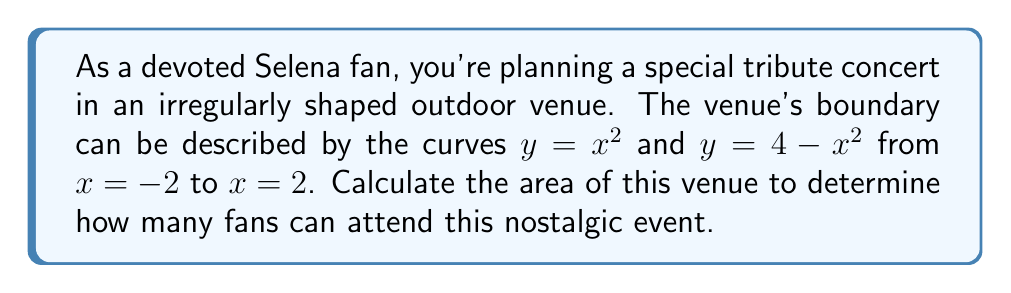Show me your answer to this math problem. To find the area of this irregularly shaped concert venue, we need to use polynomial integration. Let's approach this step-by-step:

1) The area is bounded by two curves: $y = x^2$ (lower curve) and $y = 4 - x^2$ (upper curve), from $x = -2$ to $x = 2$.

2) To find the area between these curves, we need to integrate the difference between the upper and lower functions:

   $$A = \int_{-2}^{2} [(4 - x^2) - x^2] dx$$

3) Simplify the integrand:
   $$A = \int_{-2}^{2} [4 - 2x^2] dx$$

4) Integrate:
   $$A = [4x - \frac{2x^3}{3}]_{-2}^{2}$$

5) Evaluate the integral at the bounds:
   $$A = (4(2) - \frac{2(2^3)}{3}) - (4(-2) - \frac{2(-2^3)}{3})$$
   $$A = (8 - \frac{16}{3}) - (-8 - \frac{-16}{3})$$

6) Simplify:
   $$A = (8 - \frac{16}{3}) + (8 + \frac{16}{3})$$
   $$A = 16$$

Therefore, the area of the concert venue is 16 square units.

[asy]
size(200);
import graph;

real f(real x) {return x^2;}
real g(real x) {return 4-x^2;}

draw(graph(f,-2,2),blue);
draw(graph(g,-2,2),red);

xaxis("x");
yaxis("y");

label("$y=x^2$", (2,4), SW, blue);
label("$y=4-x^2$", (-2,4), SE, red);

fill(graph(g,-2,2)--graph(f,-2,2)--cycle,gray(0.7));
[/asy]
Answer: The area of the irregularly shaped concert venue is 16 square units. 